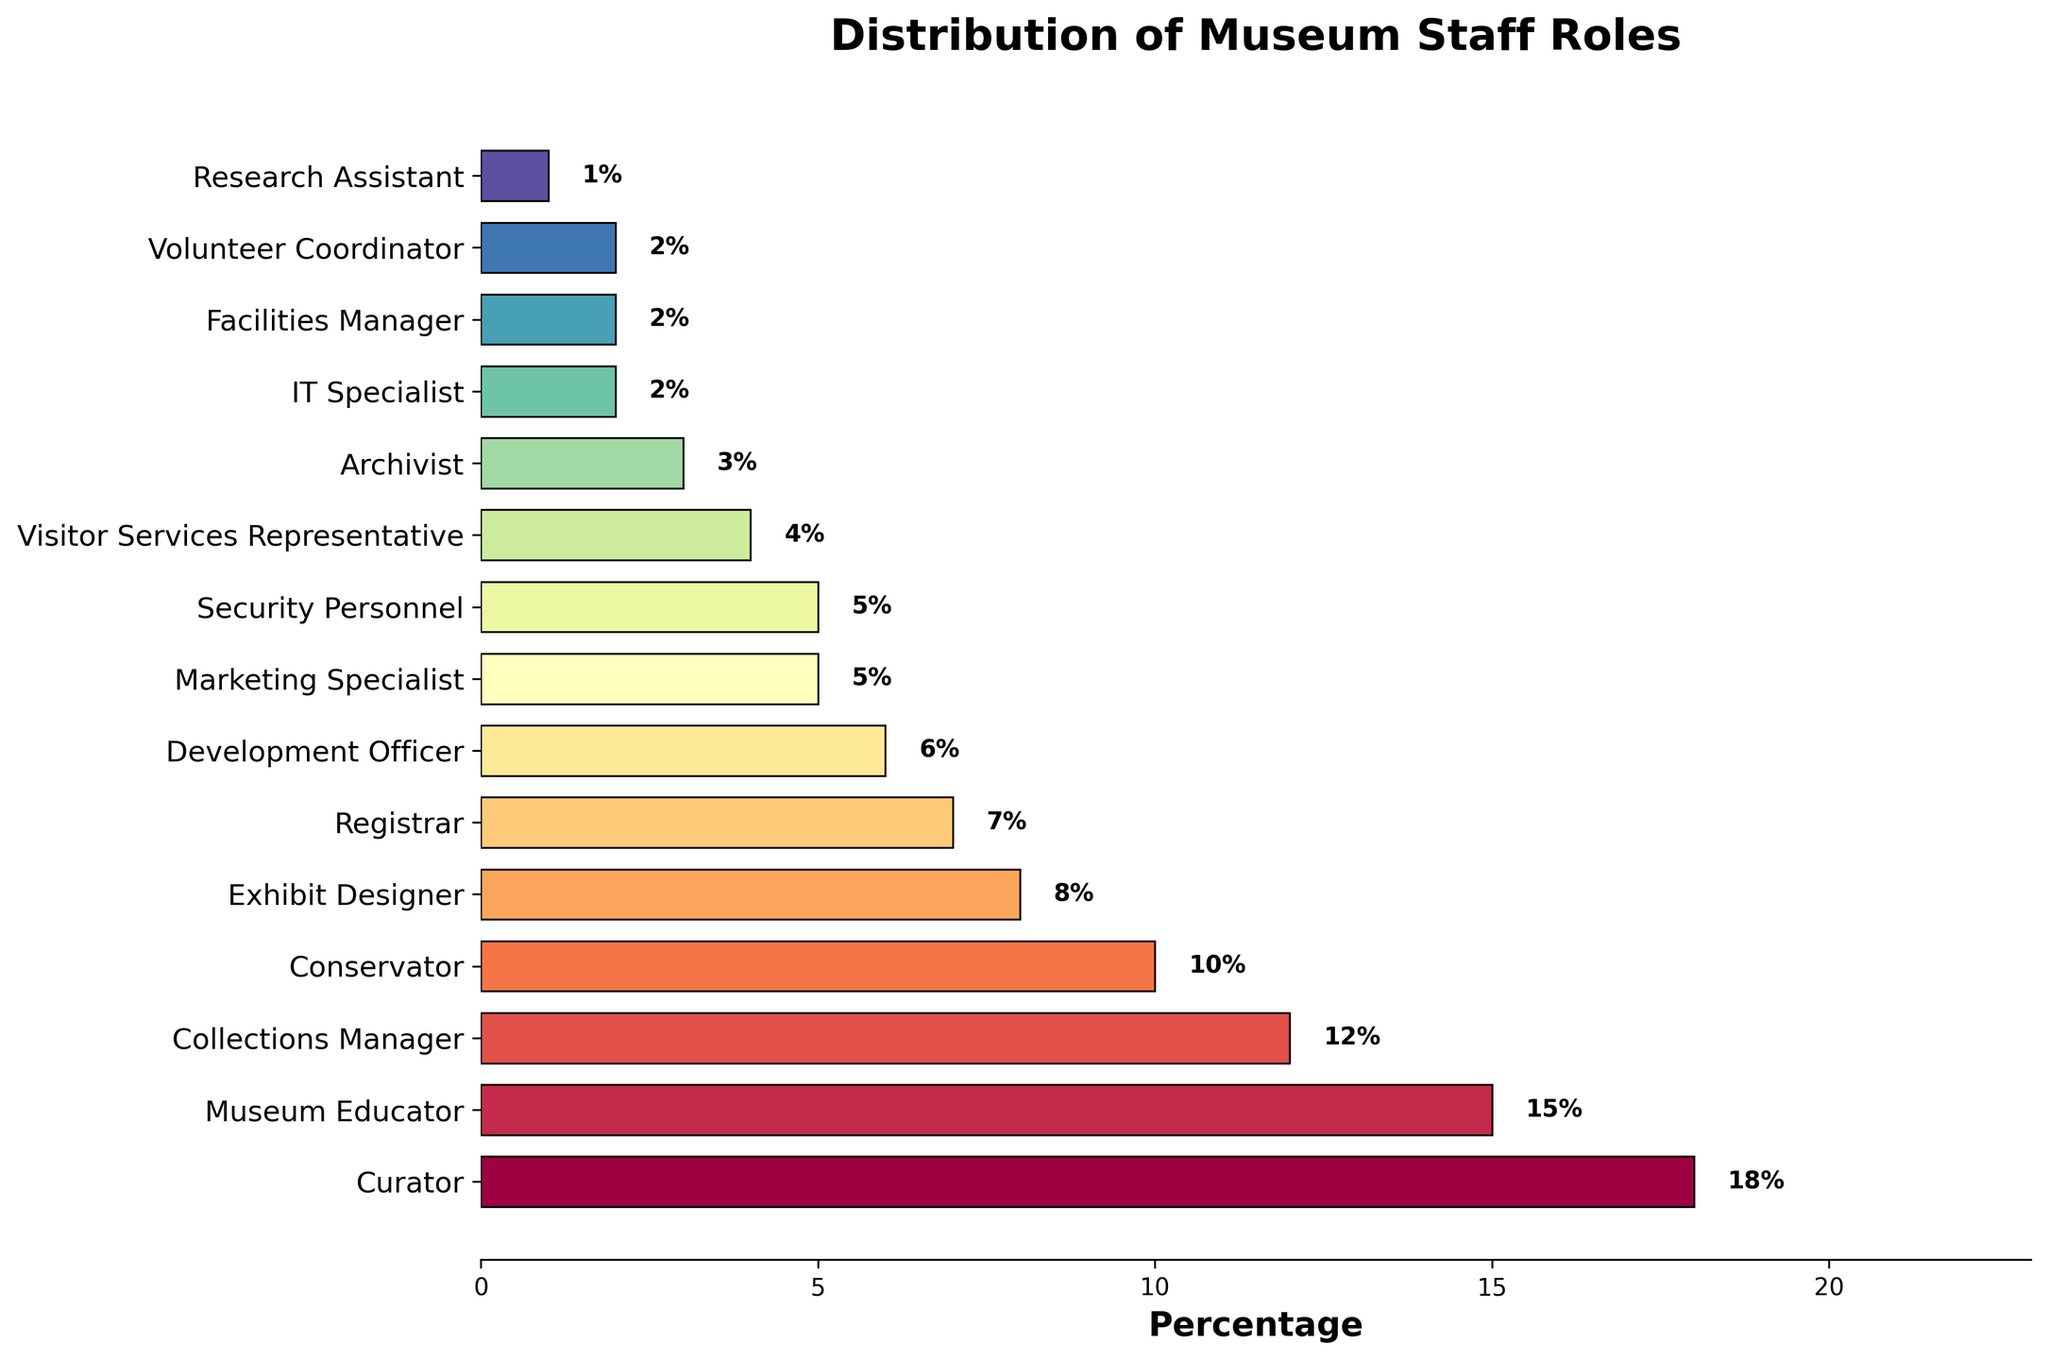What role has the highest percentage of staff allocated? Identify the bar with the greatest length, labeled "Curator" at 18%.
Answer: Curator How much more percentage does the Curator role have compared to the IT Specialist role? Subtract the percentage of IT Specialist (2%) from the Curator's (18%): 18% - 2% = 16%.
Answer: 16% Which roles have a higher percentage of staff than the Museum Educator role? Identify roles with percentages greater than 15%. Only the "Curator" role at 18% fits this criteria.
Answer: Curator What is the combined percentage of staff in the Conservator and Collections Manager roles? Add the percentages of Conservator (10%) and Collections Manager (12%): 10% + 12% = 22%.
Answer: 22% Which role has the smallest percentage of staff? Identify the bar with the shortest length, labeled "Research Assistant" at 1%.
Answer: Research Assistant How does the percentage of staff in Exhibit Designer compare to that in Development Officer? Examine the lengths of the bars labeled "Exhibit Designer" (8%) and "Development Officer" (6%), and note that Exhibit Designer is 2% higher.
Answer: Exhibit Designer has 2% more What would be the average percentage of staff for Security Personnel, Marketing Specialist, and Volunteer Coordinator roles? Sum the percentages of Security Personnel (5%), Marketing Specialist (5%), and Volunteer Coordinator (2%), then divide by 3: (5% + 5% + 2%) / 3 = 4%.
Answer: 4% How many roles have at least 10% of the staff allocated? Count the bars that represent 10% or more: Curator (18%), Museum Educator (15%), Collections Manager (12%), and Conservator (10%). There are 4 such roles.
Answer: 4 Which roles together make up exactly 20% of the staff? By combining the percentages, the only valid pair is "Collections Manager" (12%) and "Registrar" (7%), along with a slight over-count to 19% if considered together. Alternatively, the combined percentage of Security Personnel (5%) + Marketing Specialist (5%) + Visitor Services Representative (4%) + Archivist (3%) + IT Specialist (2%) + Volunteer Coordinator (2%) + Research Assistant (1%) = 22%, overshooting slightly. No exact match to 20%.
Answer: No exact match How much higher is the percentage of Museum Educators compared to Facilities Managers? Subtract the percentage of Facilities Manager (2%) from Museum Educator (15%): 15% - 2% = 13%.
Answer: 13% 